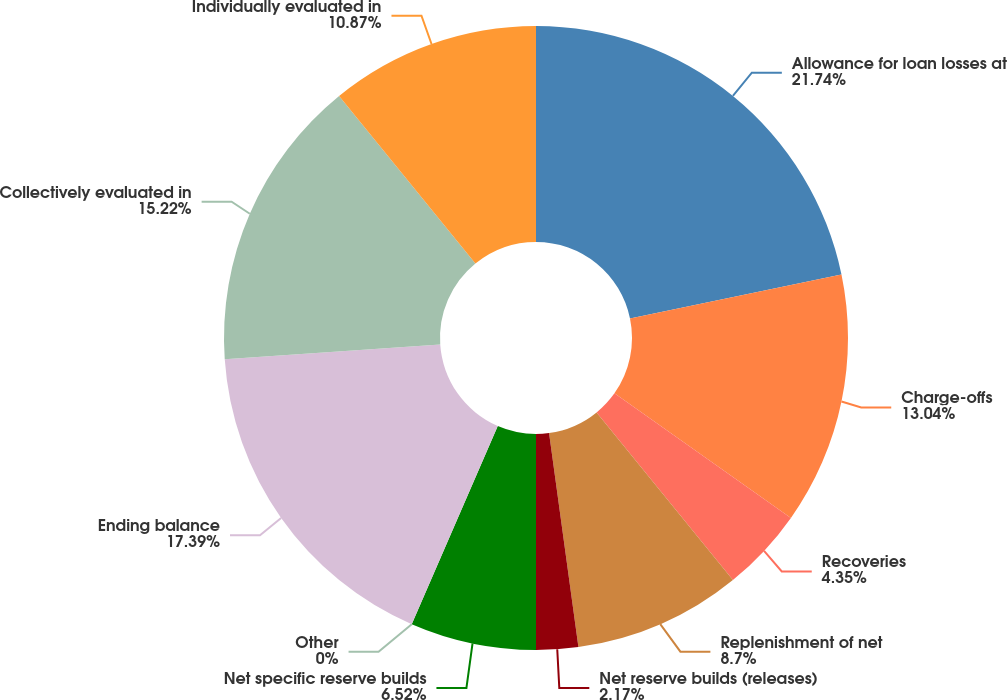Convert chart. <chart><loc_0><loc_0><loc_500><loc_500><pie_chart><fcel>Allowance for loan losses at<fcel>Charge-offs<fcel>Recoveries<fcel>Replenishment of net<fcel>Net reserve builds (releases)<fcel>Net specific reserve builds<fcel>Other<fcel>Ending balance<fcel>Collectively evaluated in<fcel>Individually evaluated in<nl><fcel>21.74%<fcel>13.04%<fcel>4.35%<fcel>8.7%<fcel>2.17%<fcel>6.52%<fcel>0.0%<fcel>17.39%<fcel>15.22%<fcel>10.87%<nl></chart> 